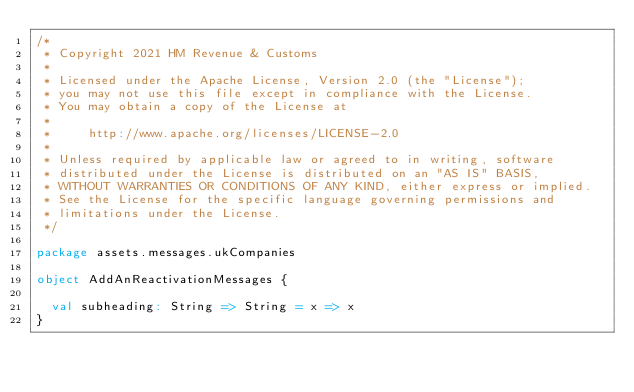Convert code to text. <code><loc_0><loc_0><loc_500><loc_500><_Scala_>/*
 * Copyright 2021 HM Revenue & Customs
 *
 * Licensed under the Apache License, Version 2.0 (the "License");
 * you may not use this file except in compliance with the License.
 * You may obtain a copy of the License at
 *
 *     http://www.apache.org/licenses/LICENSE-2.0
 *
 * Unless required by applicable law or agreed to in writing, software
 * distributed under the License is distributed on an "AS IS" BASIS,
 * WITHOUT WARRANTIES OR CONDITIONS OF ANY KIND, either express or implied.
 * See the License for the specific language governing permissions and
 * limitations under the License.
 */

package assets.messages.ukCompanies

object AddAnReactivationMessages {

  val subheading: String => String = x => x
}
</code> 